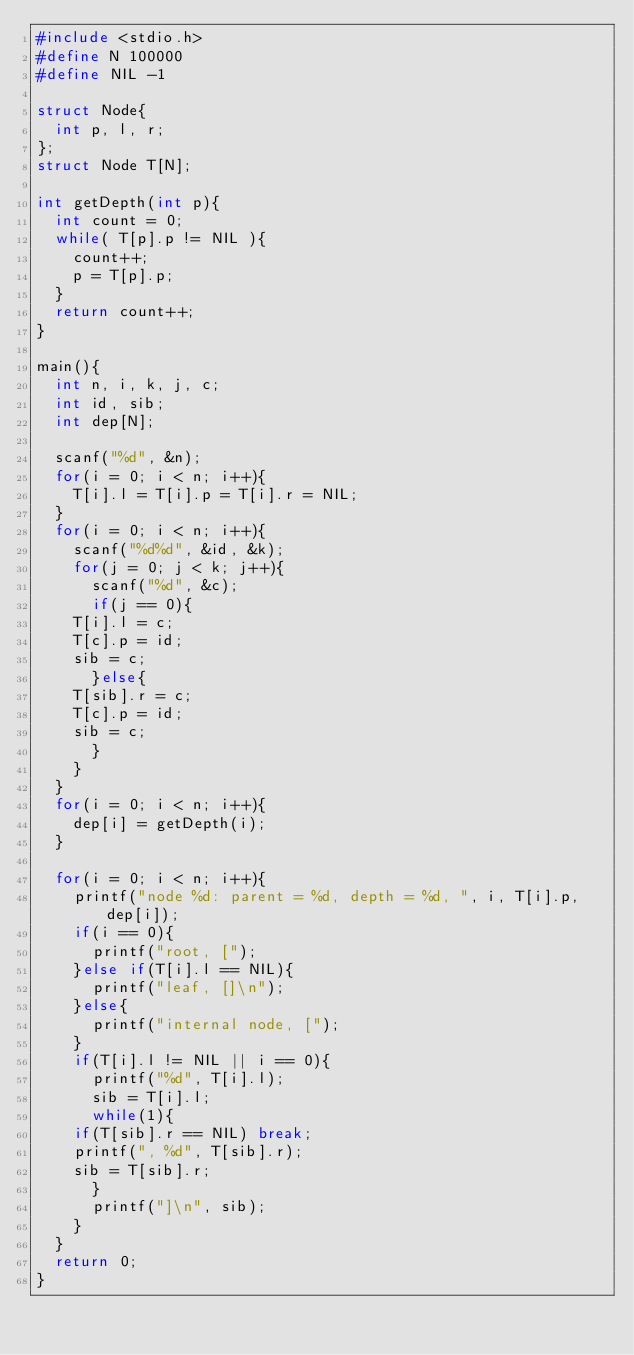Convert code to text. <code><loc_0><loc_0><loc_500><loc_500><_C_>#include <stdio.h>
#define N 100000
#define NIL -1

struct Node{
  int p, l, r;
};
struct Node T[N];

int getDepth(int p){
  int count = 0;
  while( T[p].p != NIL ){
    count++;
    p = T[p].p;
  }
  return count++;
}

main(){
  int n, i, k, j, c;
  int id, sib;
  int dep[N];

  scanf("%d", &n);
  for(i = 0; i < n; i++){
    T[i].l = T[i].p = T[i].r = NIL;
  }
  for(i = 0; i < n; i++){
    scanf("%d%d", &id, &k);
    for(j = 0; j < k; j++){
      scanf("%d", &c);
      if(j == 0){
	T[i].l = c;
	T[c].p = id;
	sib = c;
      }else{
	T[sib].r = c;
	T[c].p = id;
	sib = c;
      }
    }    
  }
  for(i = 0; i < n; i++){
    dep[i] = getDepth(i);
  }
  
  for(i = 0; i < n; i++){
    printf("node %d: parent = %d, depth = %d, ", i, T[i].p, dep[i]);
    if(i == 0){
      printf("root, [");
    }else if(T[i].l == NIL){
      printf("leaf, []\n");
    }else{
      printf("internal node, [");
    }
    if(T[i].l != NIL || i == 0){
      printf("%d", T[i].l);
      sib = T[i].l;
      while(1){
	if(T[sib].r == NIL) break;
	printf(", %d", T[sib].r);
	sib = T[sib].r;
      }
      printf("]\n", sib);
    }
  }
  return 0;
}</code> 